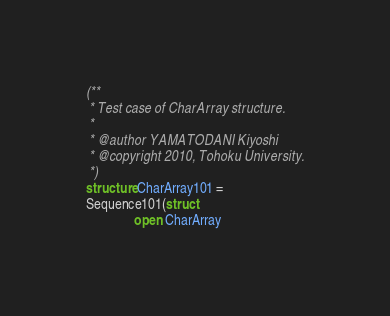Convert code to text. <code><loc_0><loc_0><loc_500><loc_500><_SML_>(**
 * Test case of CharArray structure.
 *
 * @author YAMATODANI Kiyoshi
 * @copyright 2010, Tohoku University.
 *)
structure CharArray101 = 
Sequence101(struct
              open CharArray</code> 